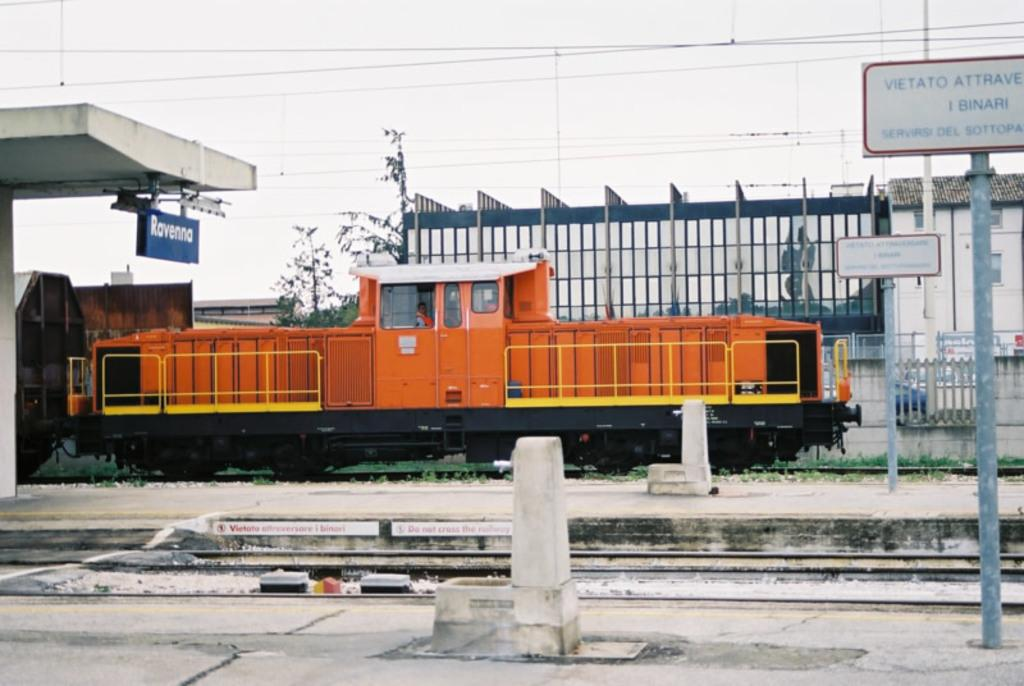<image>
Provide a brief description of the given image. Orange train next to a blue sign which says Ravenna. 